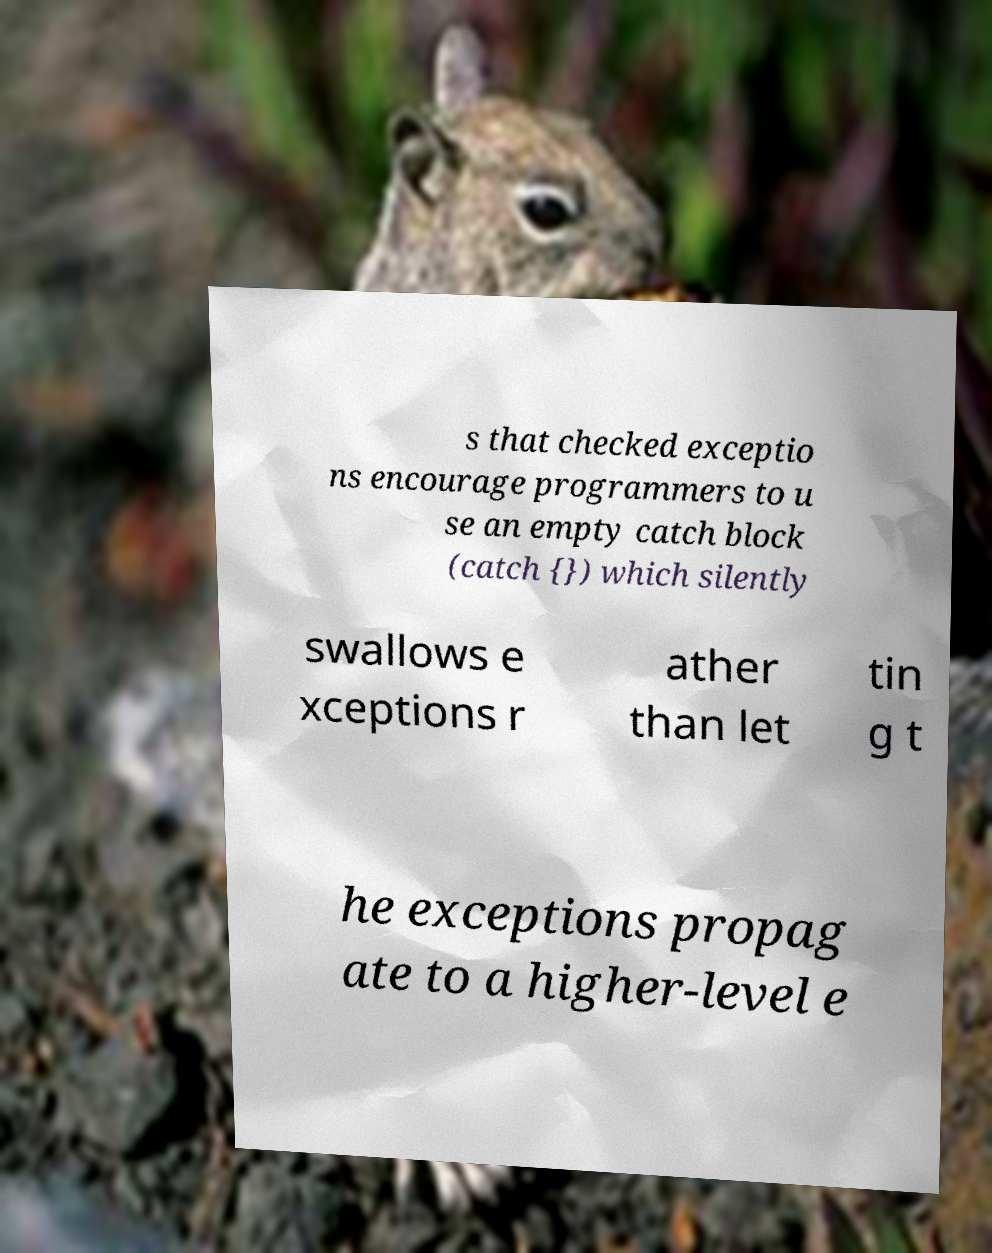Please identify and transcribe the text found in this image. s that checked exceptio ns encourage programmers to u se an empty catch block (catch {}) which silently swallows e xceptions r ather than let tin g t he exceptions propag ate to a higher-level e 